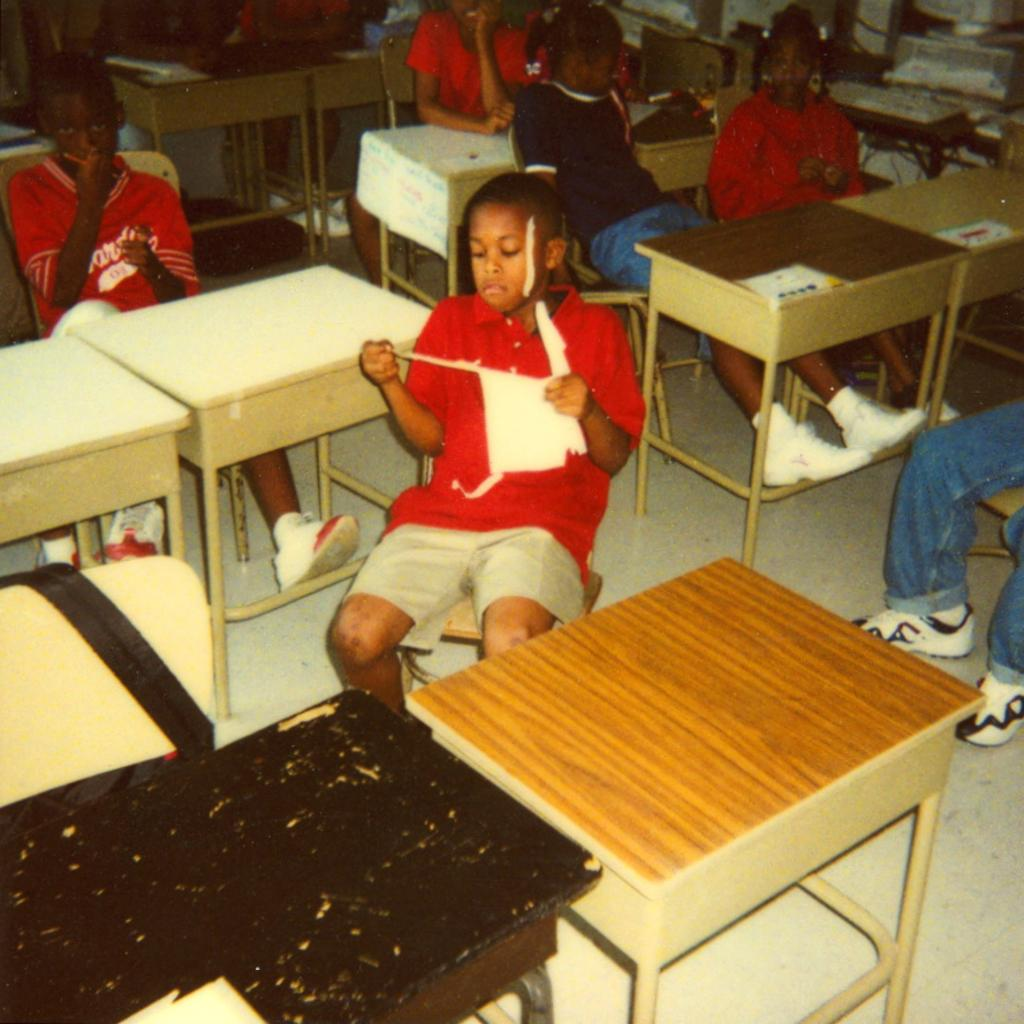What is the child in the image wearing? The child is wearing a red shirt in the image. What is the child doing in the image? The child is sitting on a chair in the image. How many children are in the image? There are many children in the image. What are the children doing in the image? The children are sitting on chairs in the image. Where are the chairs located in relation to other objects? The chairs are near tables in the image. What type of key is used to unlock the destruction caused by the knot in the image? There is no key, destruction, or knot present in the image. 